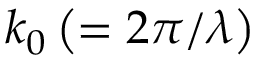<formula> <loc_0><loc_0><loc_500><loc_500>k _ { 0 } \left ( = 2 \pi / \lambda \right )</formula> 